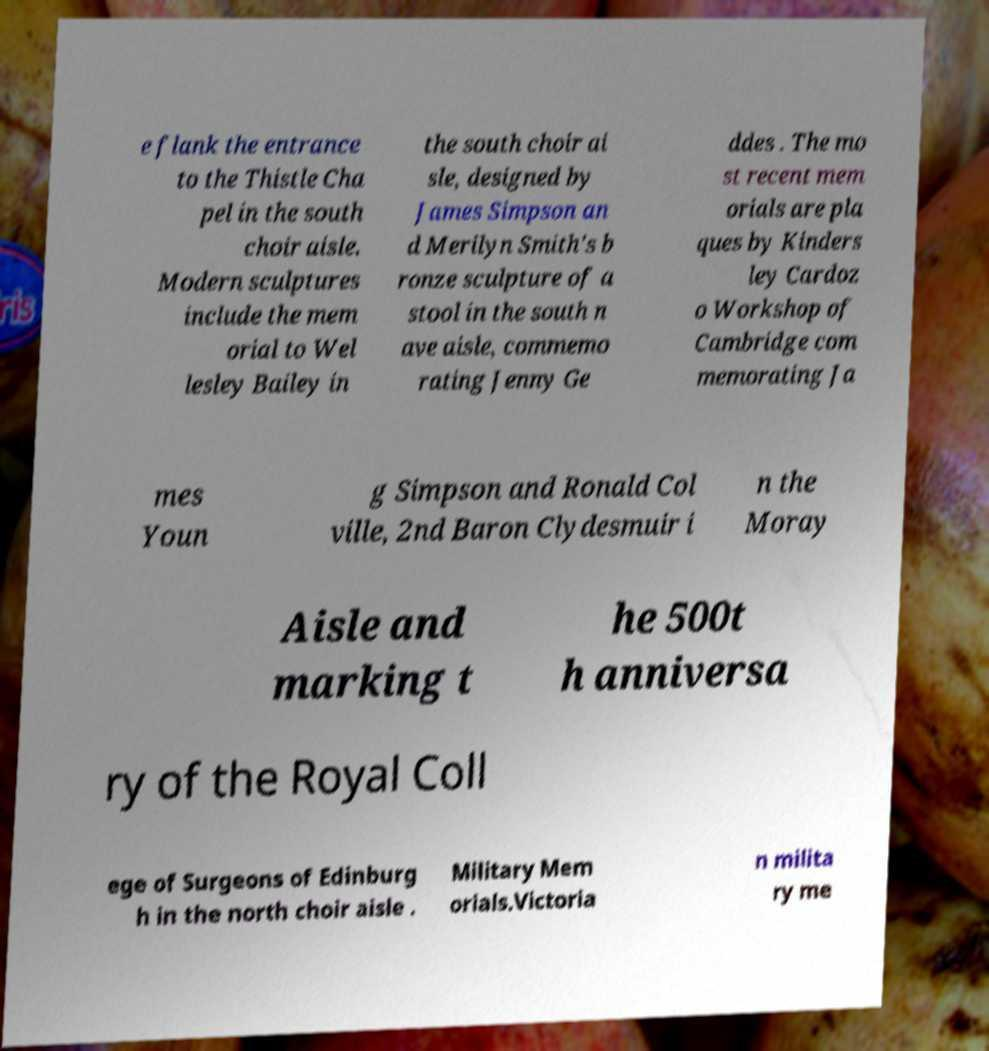Can you read and provide the text displayed in the image?This photo seems to have some interesting text. Can you extract and type it out for me? e flank the entrance to the Thistle Cha pel in the south choir aisle. Modern sculptures include the mem orial to Wel lesley Bailey in the south choir ai sle, designed by James Simpson an d Merilyn Smith's b ronze sculpture of a stool in the south n ave aisle, commemo rating Jenny Ge ddes . The mo st recent mem orials are pla ques by Kinders ley Cardoz o Workshop of Cambridge com memorating Ja mes Youn g Simpson and Ronald Col ville, 2nd Baron Clydesmuir i n the Moray Aisle and marking t he 500t h anniversa ry of the Royal Coll ege of Surgeons of Edinburg h in the north choir aisle . Military Mem orials.Victoria n milita ry me 